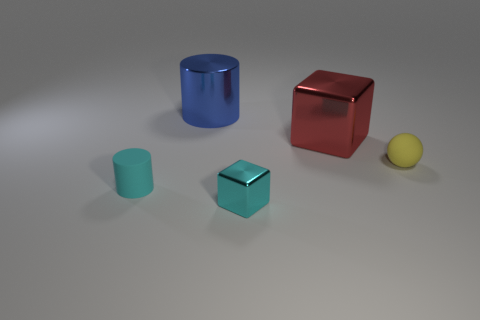Add 2 rubber cylinders. How many objects exist? 7 Subtract all cylinders. How many objects are left? 3 Add 5 small purple metallic cubes. How many small purple metallic cubes exist? 5 Subtract 0 purple spheres. How many objects are left? 5 Subtract all metal cubes. Subtract all tiny cyan metal cubes. How many objects are left? 2 Add 4 small cubes. How many small cubes are left? 5 